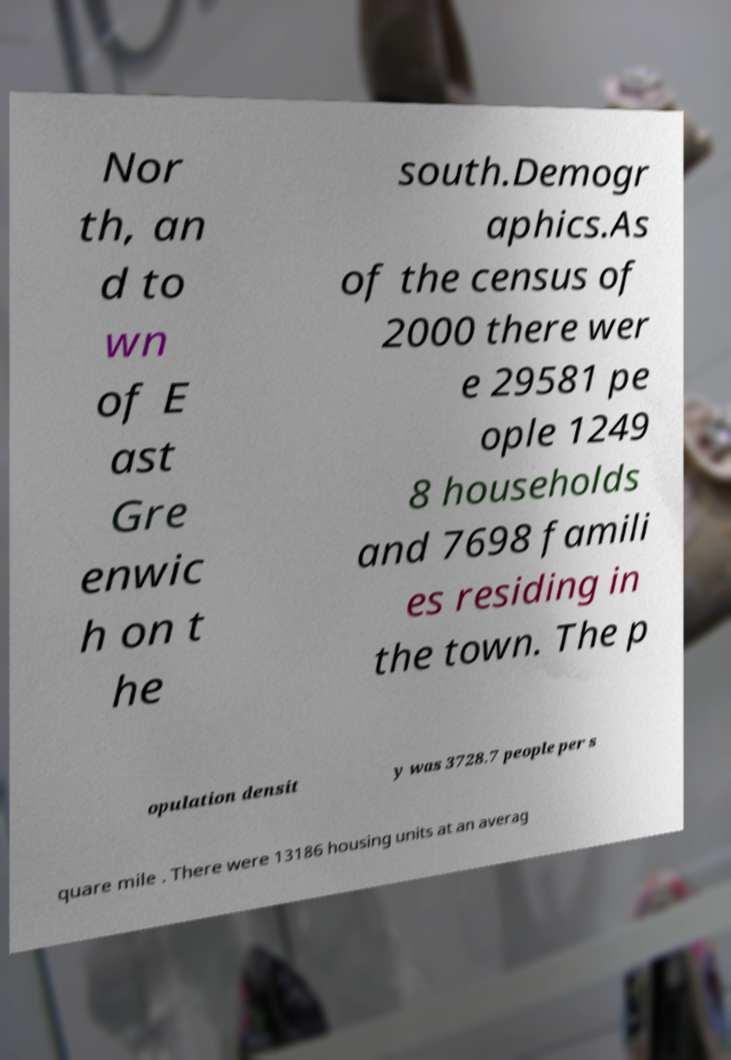What messages or text are displayed in this image? I need them in a readable, typed format. Nor th, an d to wn of E ast Gre enwic h on t he south.Demogr aphics.As of the census of 2000 there wer e 29581 pe ople 1249 8 households and 7698 famili es residing in the town. The p opulation densit y was 3728.7 people per s quare mile . There were 13186 housing units at an averag 